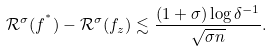<formula> <loc_0><loc_0><loc_500><loc_500>\mathcal { R } ^ { \sigma } ( f ^ { ^ { * } } ) - \mathcal { R } ^ { \sigma } ( f _ { z } ) \lesssim \frac { ( 1 + \sigma ) \log \delta ^ { - 1 } } { \sqrt { \sigma n } } .</formula> 